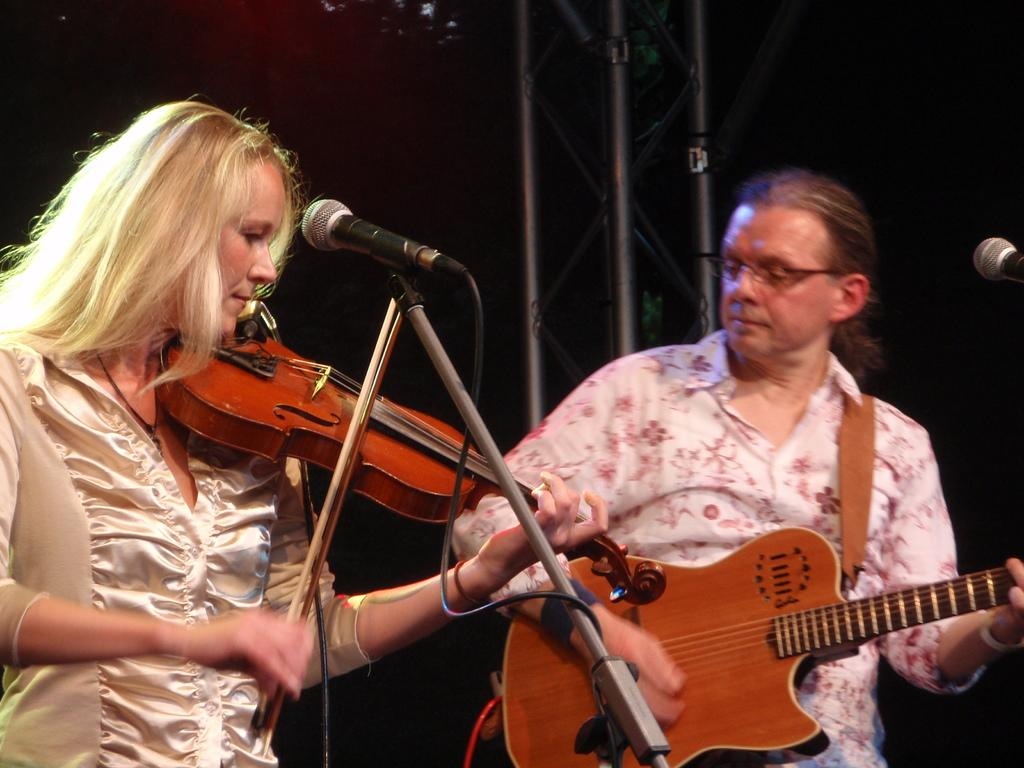What is the lady in the image doing? The lady is playing a violin in the image. What is the lady positioned in front of? The lady is in front of a microphone. What is the guy in the image doing? The guy is playing a guitar in the image. What type of cord is connected to the wrist of the lady in the image? There is no cord connected to the wrist of the lady in the image. What is the tendency of the guitar to make a certain sound in the image? The image does not provide information about the guitar's tendency to make a certain sound. 